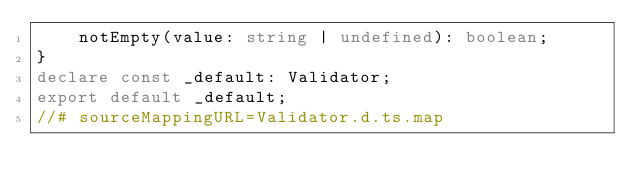<code> <loc_0><loc_0><loc_500><loc_500><_TypeScript_>    notEmpty(value: string | undefined): boolean;
}
declare const _default: Validator;
export default _default;
//# sourceMappingURL=Validator.d.ts.map</code> 